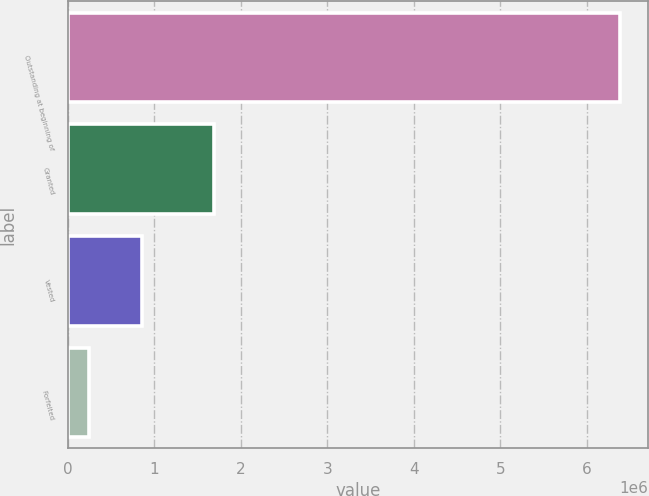<chart> <loc_0><loc_0><loc_500><loc_500><bar_chart><fcel>Outstanding at beginning of<fcel>Granted<fcel>Vested<fcel>Forfeited<nl><fcel>6.38288e+06<fcel>1.69467e+06<fcel>858093<fcel>244227<nl></chart> 